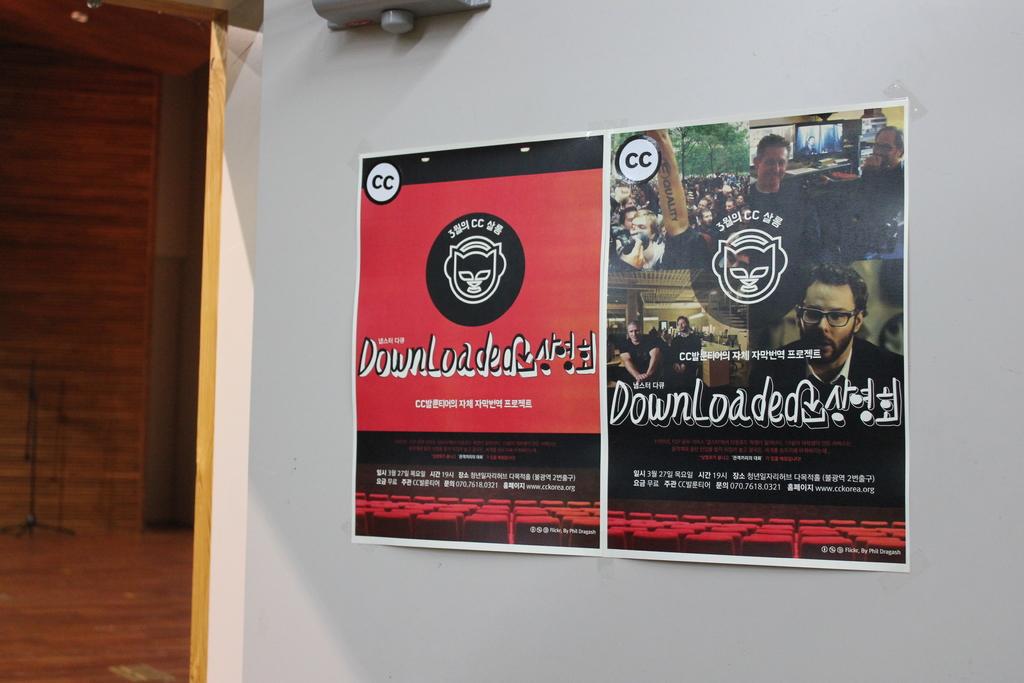What 2 letters are up in the top left corner?
Your response must be concise. Cc. 